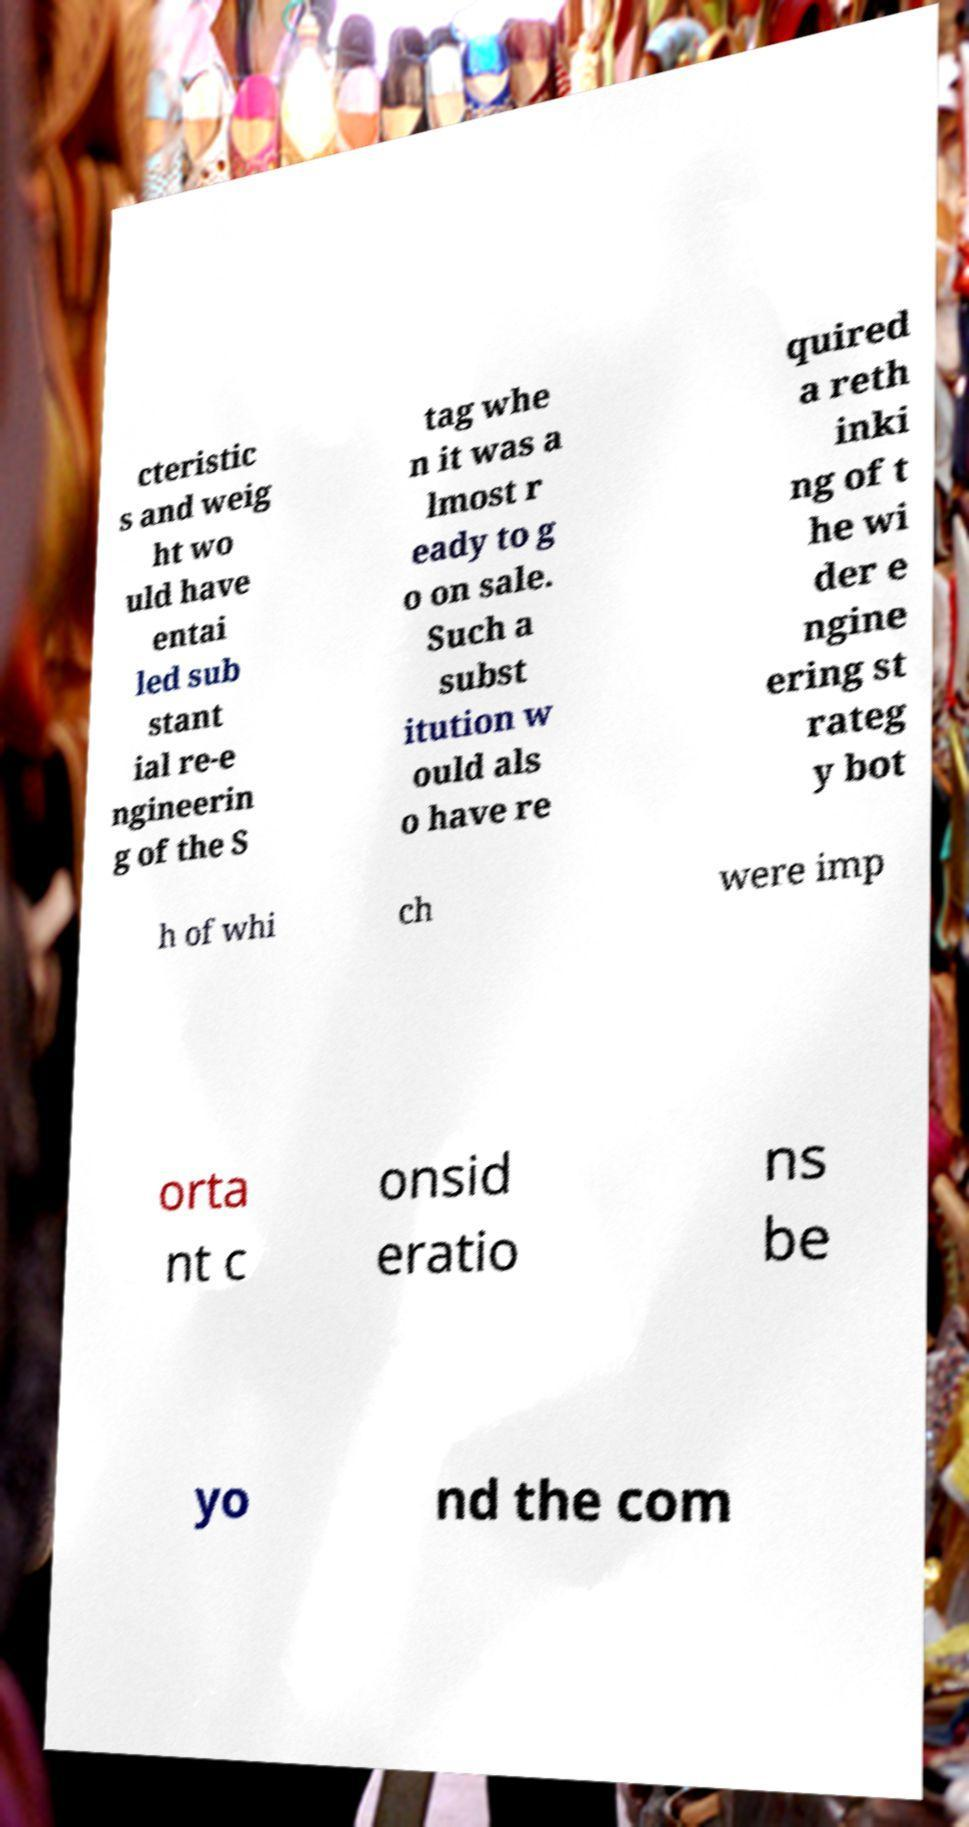Could you extract and type out the text from this image? cteristic s and weig ht wo uld have entai led sub stant ial re-e ngineerin g of the S tag whe n it was a lmost r eady to g o on sale. Such a subst itution w ould als o have re quired a reth inki ng of t he wi der e ngine ering st rateg y bot h of whi ch were imp orta nt c onsid eratio ns be yo nd the com 